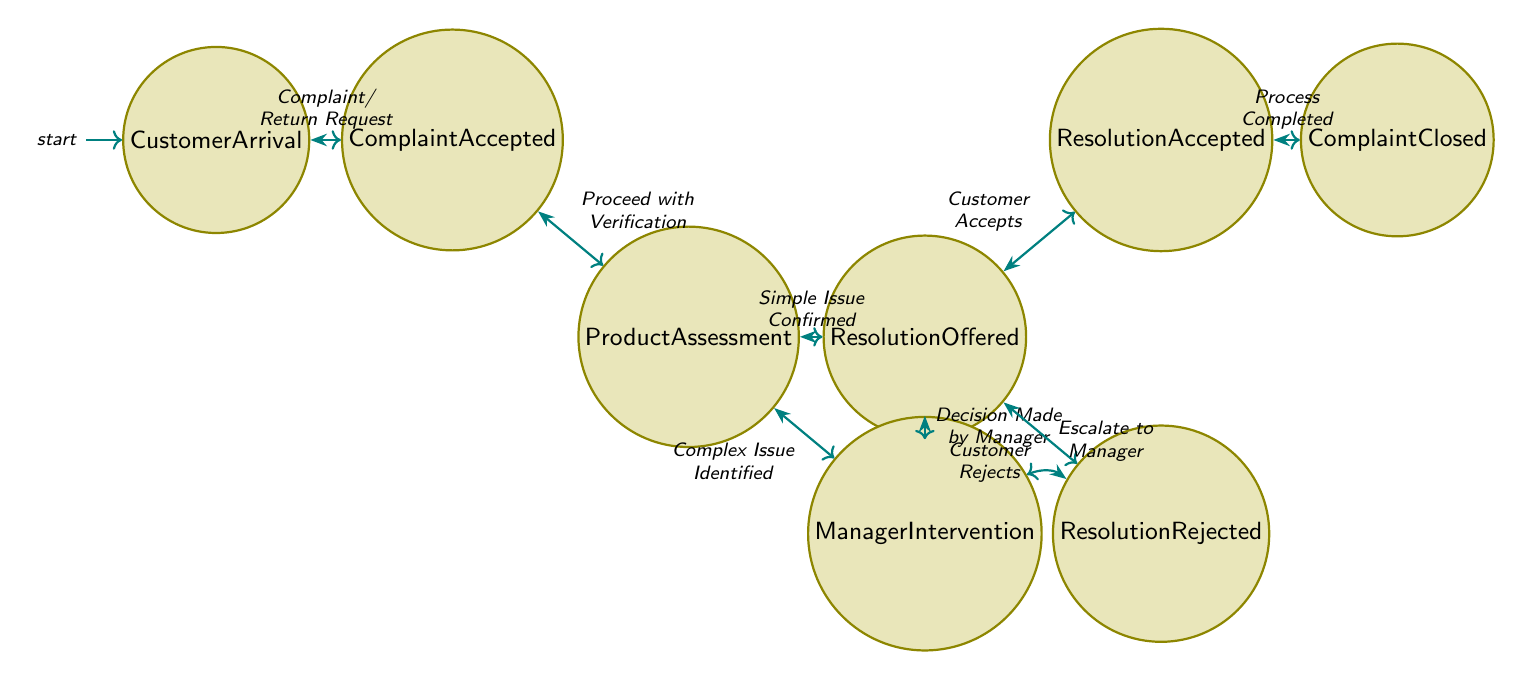What's the initial state in the diagram? The diagram starts at the state labeled "Customer Arrival," which indicates the first step in handling a customer complaint or return.
Answer: Customer Arrival How many main states are there in the diagram? The diagram shows a total of 8 main states representing various stages of the complaint handling process, from customer arrival to complaint closure.
Answer: 8 What does "Resolution Offered" lead to if the customer rejects the resolution? If the customer rejects the resolution, the diagram indicates that the process leads back to "Manager Intervention," suggesting that the case is complicated enough to require further review.
Answer: Manager Intervention What triggers the transition from "Product Assessment" to "Resolution Offered"? The transition from "Product Assessment" to "Resolution Offered" is triggered when a simple issue is confirmed after the product is assessed by the staff member.
Answer: Simple Issue Confirmed How does the diagram conclude the complaint process? The complaint process concludes at the state labeled "Complaint Closed," which is reached when the customer accepts the resolution offered by the staff member.
Answer: Complaint Closed If a complex issue is identified during assessment, what role does the manager play? When a complex issue is identified, the manager intervenes to make a decision regarding how to resolve the situation, indicating their role as a higher authority in complicated cases.
Answer: Manager Intervention How many transitions are there between the states in the diagram? There are 8 transitions illustrated in the diagram, connecting various states based on triggers that allow the process to flow smoothly from arrival to closure.
Answer: 8 What happens after "Resolution Accepted"? Once "Resolution Accepted" is reached, the next step is "Complaint Closed," which signifies that the complaint handling process has been successfully completed after the resolution is accepted by the customer.
Answer: Complaint Closed 